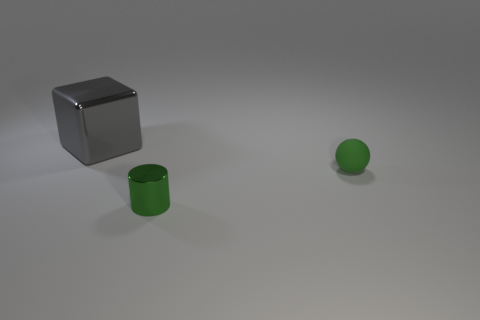What shape is the thing that is the same size as the cylinder?
Your response must be concise. Sphere. What number of large metallic cubes are the same color as the shiny cylinder?
Ensure brevity in your answer.  0. Is the number of tiny objects that are in front of the sphere less than the number of tiny green things to the right of the large gray shiny block?
Provide a short and direct response. Yes. There is a gray metallic cube; are there any small green metal objects in front of it?
Provide a succinct answer. Yes. Is there a small thing that is behind the small thing on the left side of the object on the right side of the green shiny object?
Give a very brief answer. Yes. The tiny object that is the same material as the gray cube is what color?
Offer a very short reply. Green. How many large objects have the same material as the tiny green sphere?
Your answer should be very brief. 0. There is a shiny object in front of the tiny green thing that is right of the tiny thing that is to the left of the matte thing; what is its color?
Offer a very short reply. Green. Is the size of the ball the same as the cylinder?
Your answer should be compact. Yes. Is there any other thing that is the same shape as the green rubber thing?
Provide a succinct answer. No. 